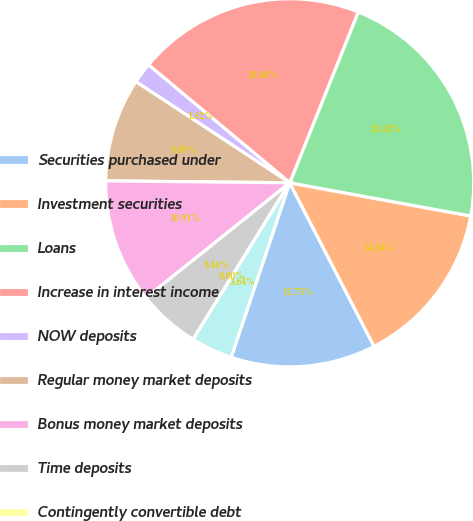<chart> <loc_0><loc_0><loc_500><loc_500><pie_chart><fcel>Securities purchased under<fcel>Investment securities<fcel>Loans<fcel>Increase in interest income<fcel>NOW deposits<fcel>Regular money market deposits<fcel>Bonus money market deposits<fcel>Time deposits<fcel>Contingently convertible debt<fcel>Junior subordinated debentures<nl><fcel>12.73%<fcel>14.54%<fcel>21.82%<fcel>20.0%<fcel>1.82%<fcel>9.09%<fcel>10.91%<fcel>5.46%<fcel>0.0%<fcel>3.64%<nl></chart> 